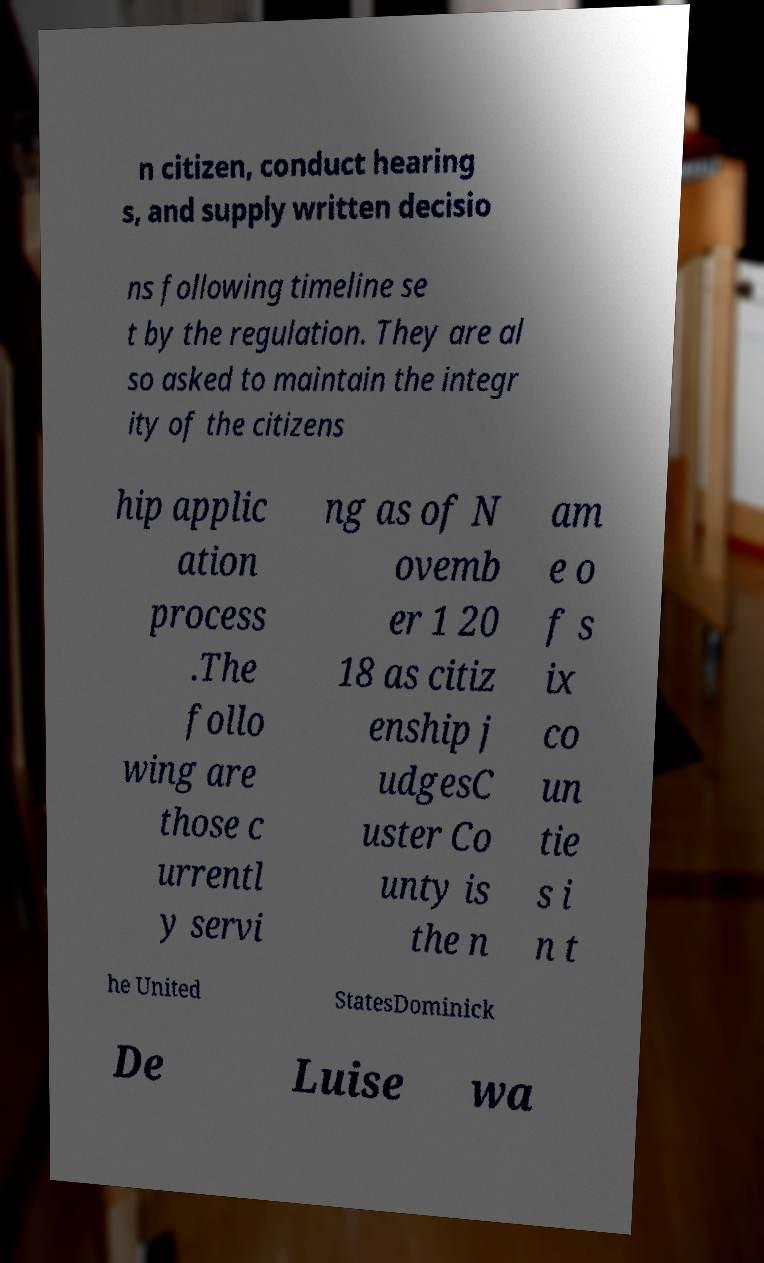Can you accurately transcribe the text from the provided image for me? n citizen, conduct hearing s, and supply written decisio ns following timeline se t by the regulation. They are al so asked to maintain the integr ity of the citizens hip applic ation process .The follo wing are those c urrentl y servi ng as of N ovemb er 1 20 18 as citiz enship j udgesC uster Co unty is the n am e o f s ix co un tie s i n t he United StatesDominick De Luise wa 